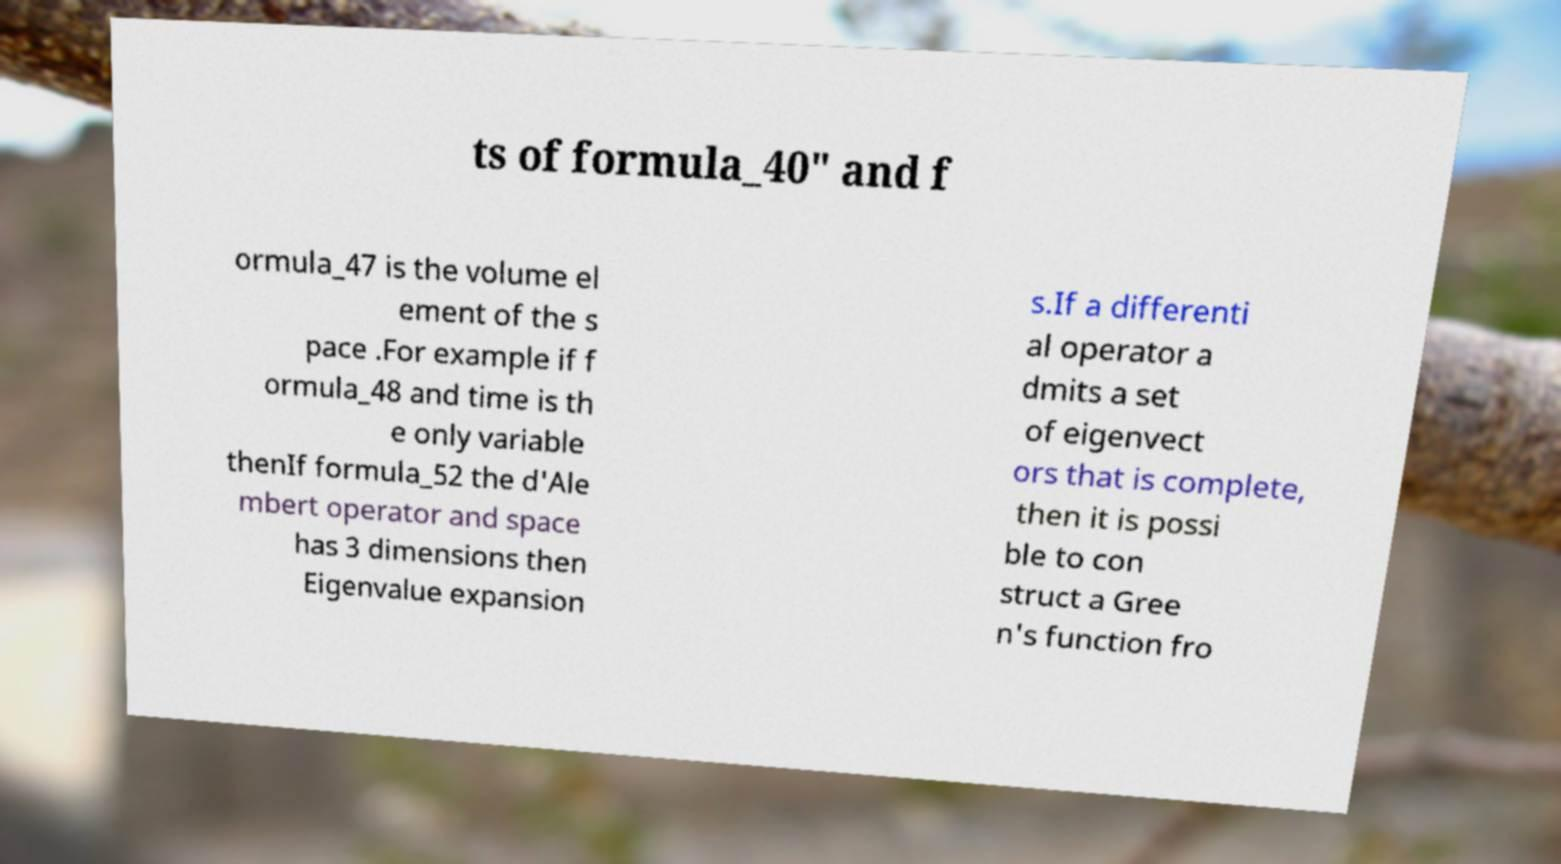Could you extract and type out the text from this image? ts of formula_40" and f ormula_47 is the volume el ement of the s pace .For example if f ormula_48 and time is th e only variable thenIf formula_52 the d'Ale mbert operator and space has 3 dimensions then Eigenvalue expansion s.If a differenti al operator a dmits a set of eigenvect ors that is complete, then it is possi ble to con struct a Gree n's function fro 